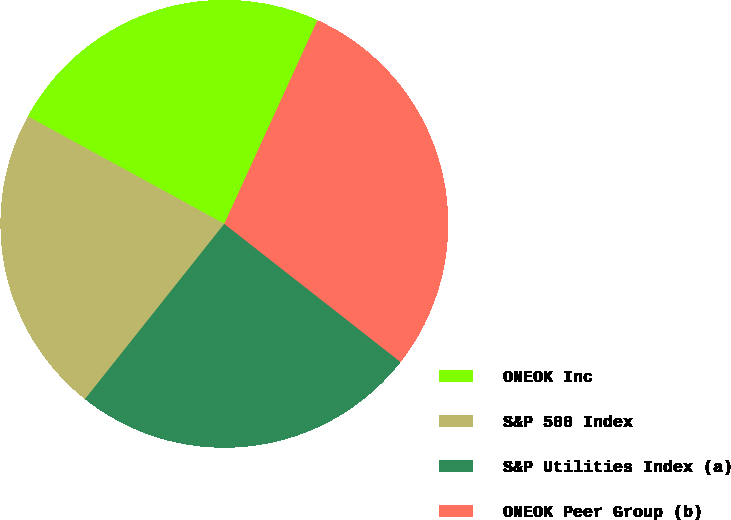Convert chart to OTSL. <chart><loc_0><loc_0><loc_500><loc_500><pie_chart><fcel>ONEOK Inc<fcel>S&P 500 Index<fcel>S&P Utilities Index (a)<fcel>ONEOK Peer Group (b)<nl><fcel>23.87%<fcel>22.28%<fcel>25.11%<fcel>28.75%<nl></chart> 